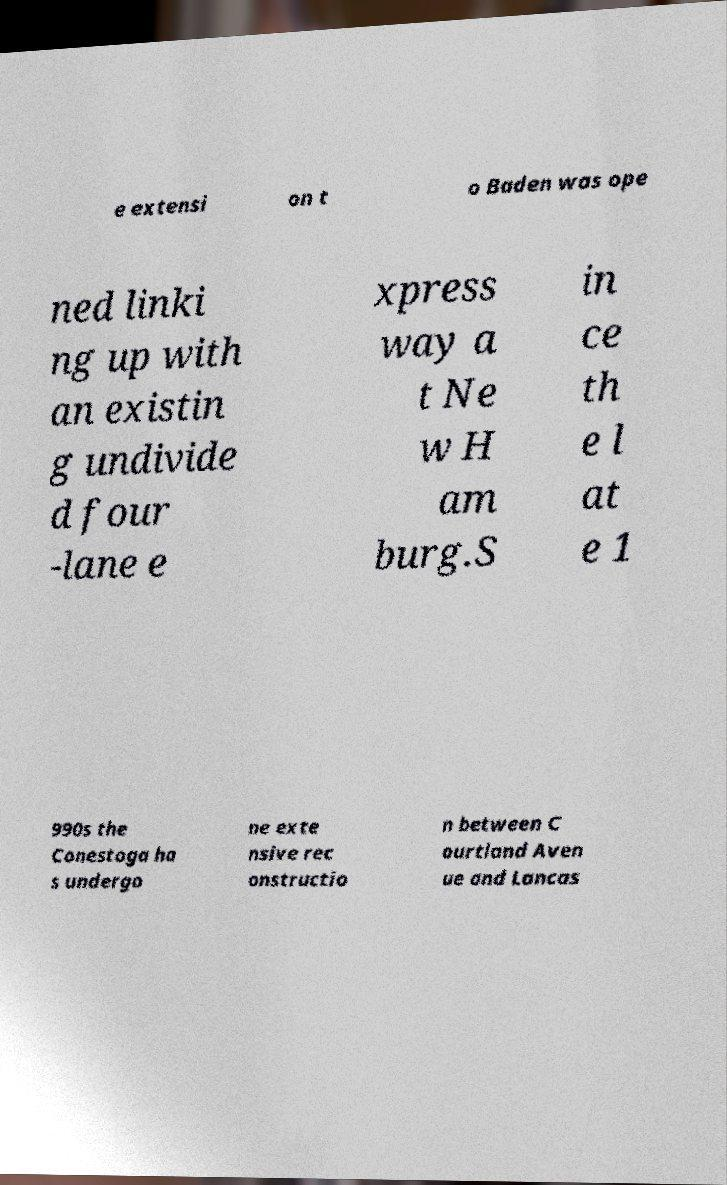Could you assist in decoding the text presented in this image and type it out clearly? e extensi on t o Baden was ope ned linki ng up with an existin g undivide d four -lane e xpress way a t Ne w H am burg.S in ce th e l at e 1 990s the Conestoga ha s undergo ne exte nsive rec onstructio n between C ourtland Aven ue and Lancas 